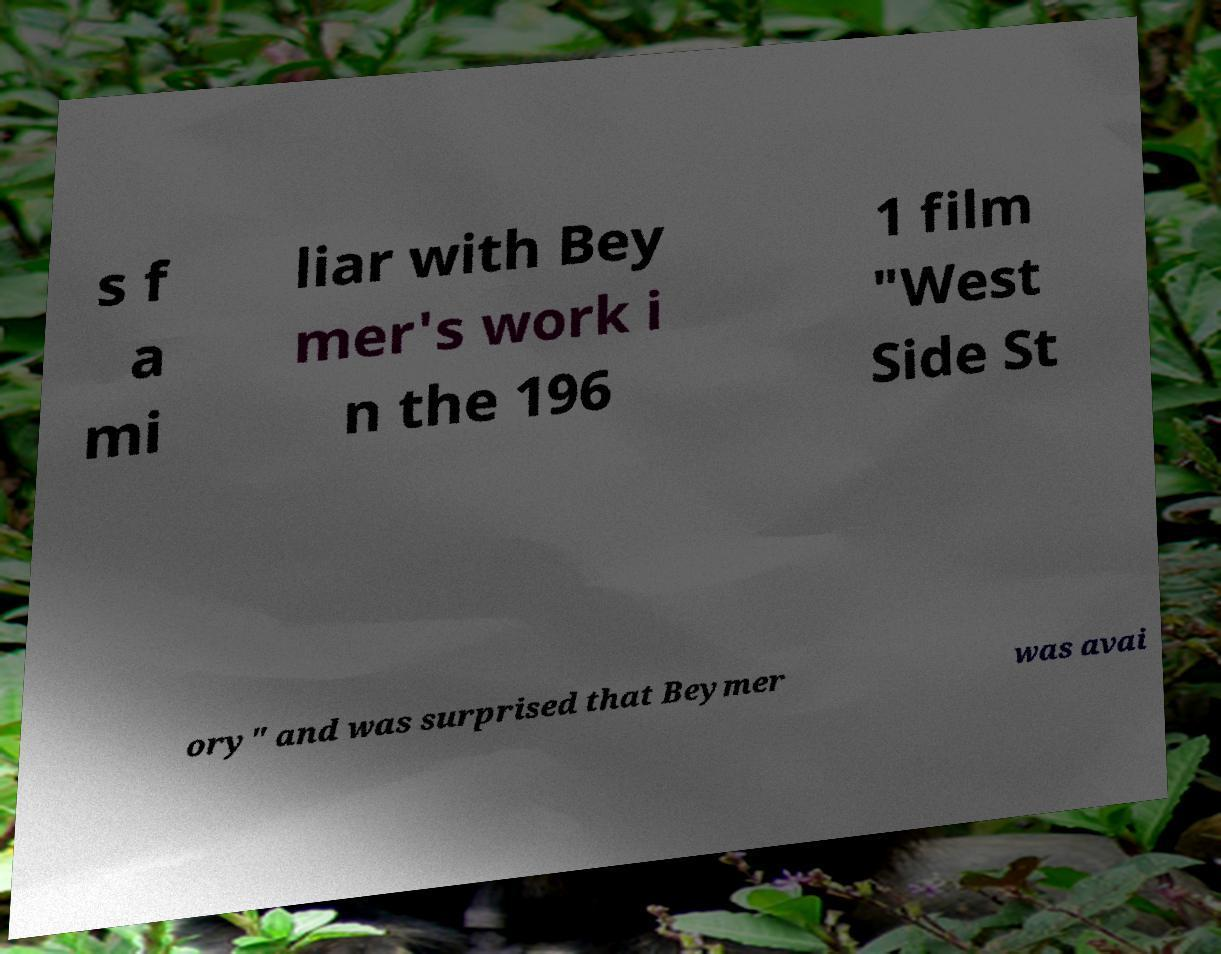Could you extract and type out the text from this image? s f a mi liar with Bey mer's work i n the 196 1 film "West Side St ory" and was surprised that Beymer was avai 